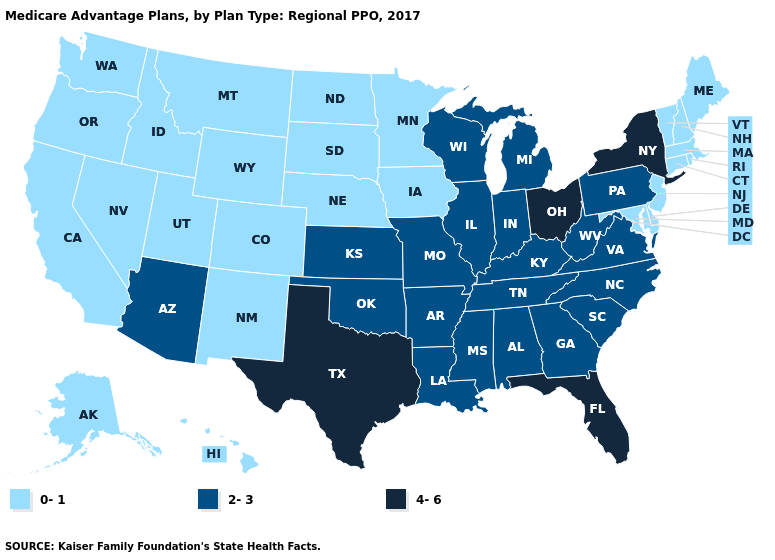What is the value of Tennessee?
Concise answer only. 2-3. Which states have the lowest value in the West?
Write a very short answer. Alaska, California, Colorado, Hawaii, Idaho, Montana, New Mexico, Nevada, Oregon, Utah, Washington, Wyoming. Does Oregon have the lowest value in the West?
Give a very brief answer. Yes. What is the value of Mississippi?
Give a very brief answer. 2-3. Among the states that border Wisconsin , does Michigan have the lowest value?
Answer briefly. No. Does Florida have the highest value in the USA?
Quick response, please. Yes. Which states have the lowest value in the South?
Keep it brief. Delaware, Maryland. What is the lowest value in the South?
Be succinct. 0-1. What is the lowest value in the USA?
Keep it brief. 0-1. Name the states that have a value in the range 0-1?
Answer briefly. Alaska, California, Colorado, Connecticut, Delaware, Hawaii, Iowa, Idaho, Massachusetts, Maryland, Maine, Minnesota, Montana, North Dakota, Nebraska, New Hampshire, New Jersey, New Mexico, Nevada, Oregon, Rhode Island, South Dakota, Utah, Vermont, Washington, Wyoming. Name the states that have a value in the range 2-3?
Give a very brief answer. Alabama, Arkansas, Arizona, Georgia, Illinois, Indiana, Kansas, Kentucky, Louisiana, Michigan, Missouri, Mississippi, North Carolina, Oklahoma, Pennsylvania, South Carolina, Tennessee, Virginia, Wisconsin, West Virginia. Which states hav the highest value in the South?
Concise answer only. Florida, Texas. Among the states that border Arizona , which have the lowest value?
Short answer required. California, Colorado, New Mexico, Nevada, Utah. What is the lowest value in the USA?
Be succinct. 0-1. 